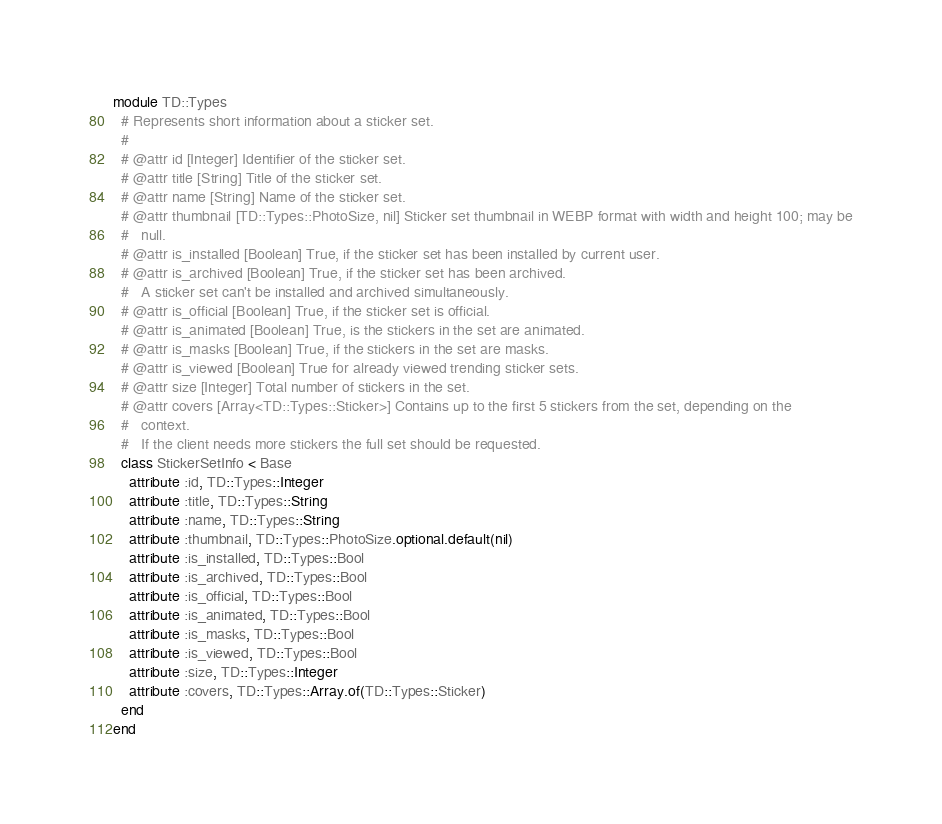Convert code to text. <code><loc_0><loc_0><loc_500><loc_500><_Ruby_>module TD::Types
  # Represents short information about a sticker set.
  #
  # @attr id [Integer] Identifier of the sticker set.
  # @attr title [String] Title of the sticker set.
  # @attr name [String] Name of the sticker set.
  # @attr thumbnail [TD::Types::PhotoSize, nil] Sticker set thumbnail in WEBP format with width and height 100; may be
  #   null.
  # @attr is_installed [Boolean] True, if the sticker set has been installed by current user.
  # @attr is_archived [Boolean] True, if the sticker set has been archived.
  #   A sticker set can't be installed and archived simultaneously.
  # @attr is_official [Boolean] True, if the sticker set is official.
  # @attr is_animated [Boolean] True, is the stickers in the set are animated.
  # @attr is_masks [Boolean] True, if the stickers in the set are masks.
  # @attr is_viewed [Boolean] True for already viewed trending sticker sets.
  # @attr size [Integer] Total number of stickers in the set.
  # @attr covers [Array<TD::Types::Sticker>] Contains up to the first 5 stickers from the set, depending on the
  #   context.
  #   If the client needs more stickers the full set should be requested.
  class StickerSetInfo < Base
    attribute :id, TD::Types::Integer
    attribute :title, TD::Types::String
    attribute :name, TD::Types::String
    attribute :thumbnail, TD::Types::PhotoSize.optional.default(nil)
    attribute :is_installed, TD::Types::Bool
    attribute :is_archived, TD::Types::Bool
    attribute :is_official, TD::Types::Bool
    attribute :is_animated, TD::Types::Bool
    attribute :is_masks, TD::Types::Bool
    attribute :is_viewed, TD::Types::Bool
    attribute :size, TD::Types::Integer
    attribute :covers, TD::Types::Array.of(TD::Types::Sticker)
  end
end
</code> 